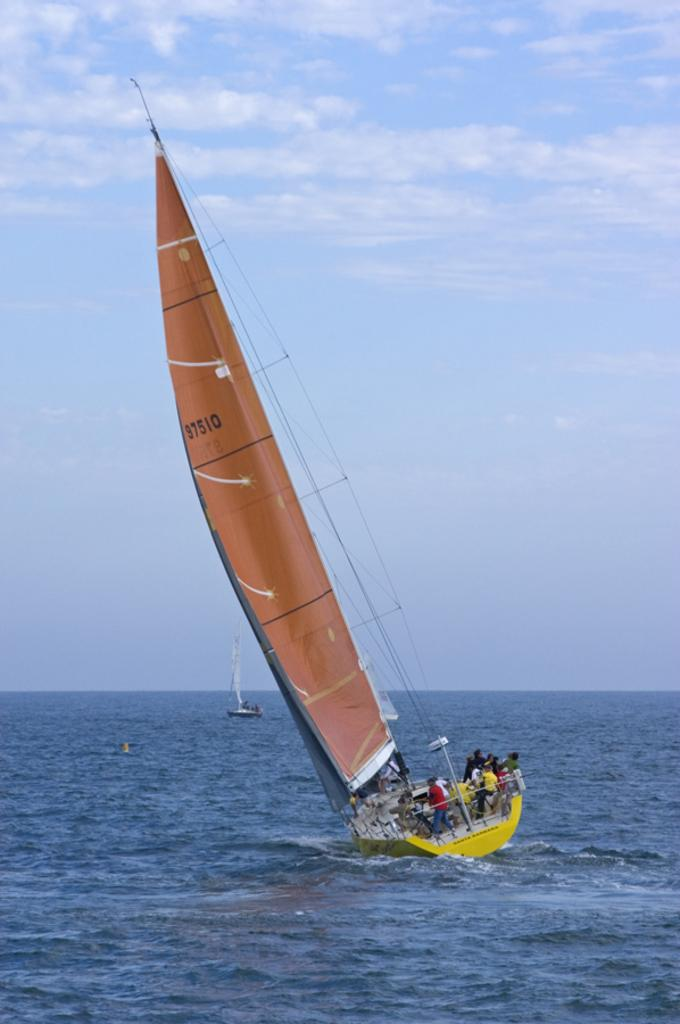What is the main subject of the image? The main subject of the image is persons in a ship. Where is the ship located? The ship is on water. What can be seen in the sky in the image? The sky is visible in the image, and there are clouds present. What type of bear can be seen participating in the winter activity in the image? There is no bear or winter activity present in the image. 